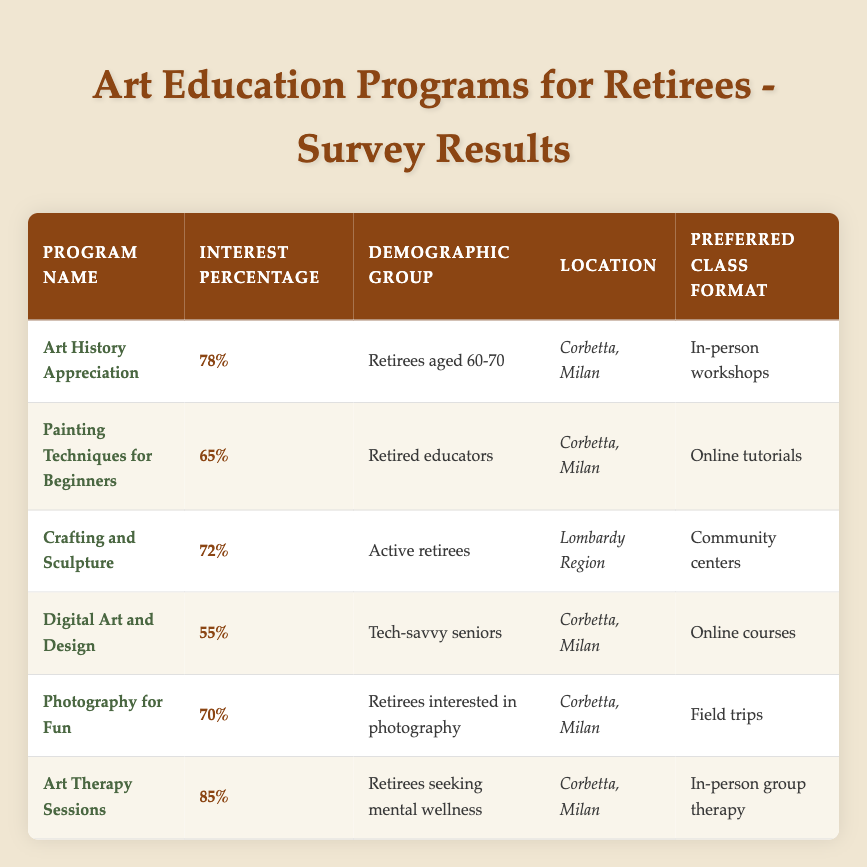What is the highest interest percentage in the survey? The survey data shows that "Art Therapy Sessions" has the highest interest percentage of 85%. I locate this from the table by comparing all the interest percentages listed.
Answer: 85% Which program has the lowest interest percentage? From the table, I can see that "Digital Art and Design" has the lowest interest percentage at 55%. This is confirmed by reviewing the percentage values in the table.
Answer: 55% How many programs are offered to retirees in Corbetta, Milan? There are four programs listed in the table that specify "Corbetta, Milan" as their location: "Art History Appreciation," "Painting Techniques for Beginners," "Digital Art and Design," and "Photography for Fun." I count these to find the total.
Answer: 4 What is the average interest percentage for programs targeted at retirees living in Corbetta, Milan? The interest percentages for the four programs located in Corbetta, Milan are 78%, 65%, 55%, and 70%. To find the average, I first sum these percentages: 78 + 65 + 55 + 70 = 268. Then, I divide by 4 (the number of programs): 268 / 4 = 67.
Answer: 67 Is there a program for retired educators in Corbetta, Milan? Yes, the program "Painting Techniques for Beginners" is specifically targeted at retired educators and is located in Corbetta, Milan. This is confirmed by checking the demographic group and location for that program in the table.
Answer: Yes Do active retirees prefer in-person workshops? From the table, "Crafting and Sculpture," which is for active retirees, prefers "Community centers" for its class format. Therefore, while there's interest, their preferred format isn't specifically in-person workshops. I check the preferred class format in the table for this detail.
Answer: No Which program, among those listed, has a higher interest percentage: "Photography for Fun" or "Crafting and Sculpture"? I look at the interest percentages in the table: "Photography for Fun" has 70% and "Crafting and Sculpture" has 72%. Since 72% is greater than 70%, "Crafting and Sculpture" has a higher percentage.
Answer: Crafting and Sculpture What percentage of the surveyed retirees prefer online tutorials? Only one program, "Painting Techniques for Beginners," lists "Online tutorials" as its preferred format, with an interest percentage of 65%. Thus, I can directly refer to this entry in the table to provide the answer.
Answer: 65 Which program has a preference for field trips? "Photography for Fun" is the program mentioned in the table that has field trips as its preferred class format. I find this from the class format column corresponding to the program name.
Answer: Photography for Fun 